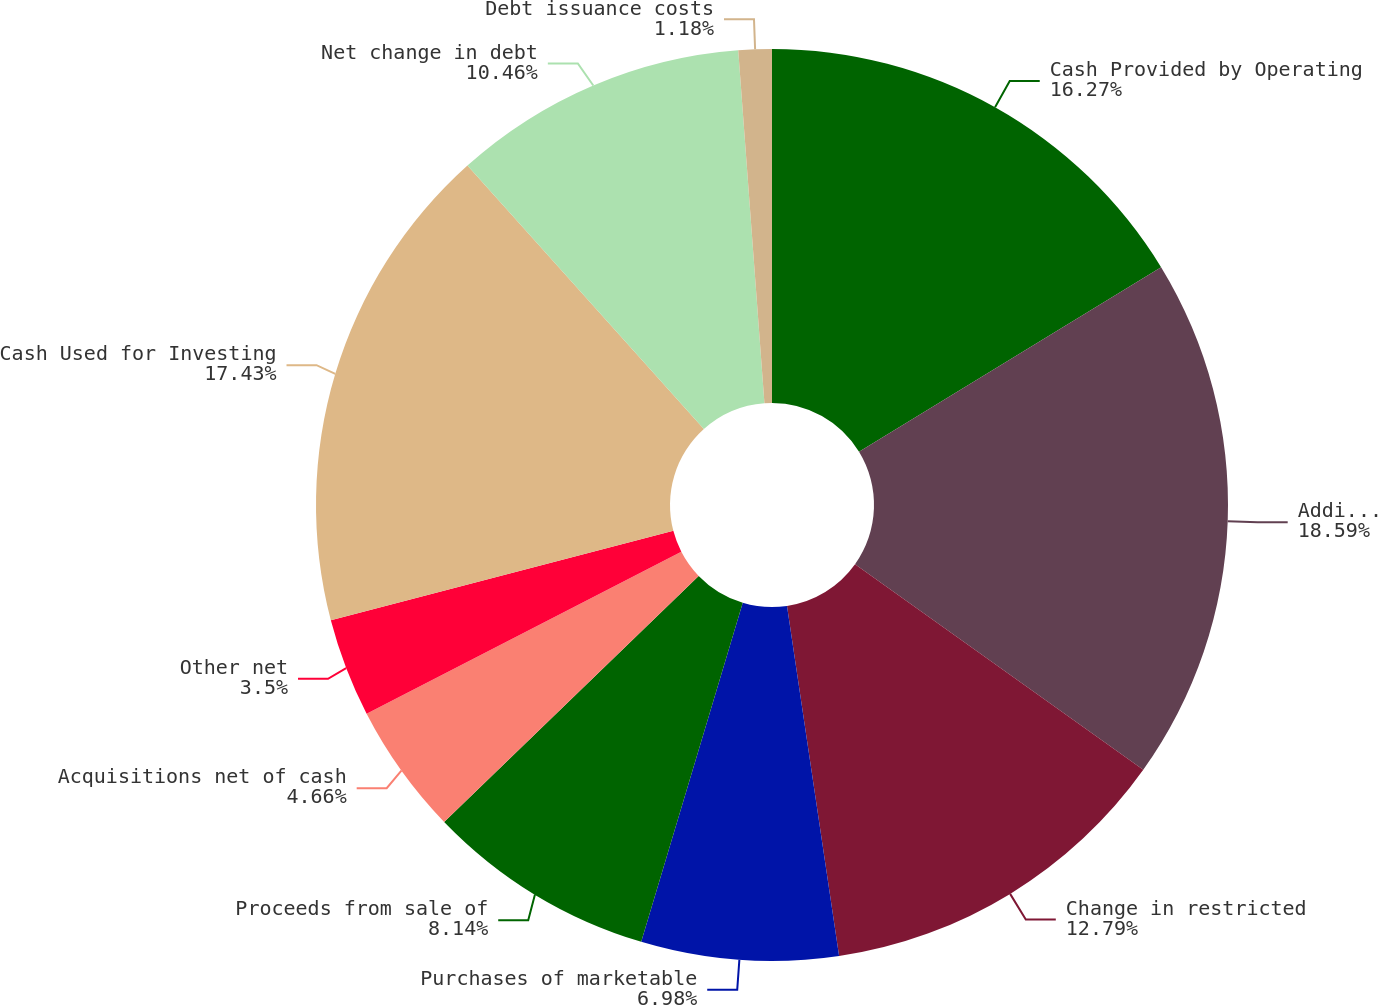Convert chart to OTSL. <chart><loc_0><loc_0><loc_500><loc_500><pie_chart><fcel>Cash Provided by Operating<fcel>Additions to property plant<fcel>Change in restricted<fcel>Purchases of marketable<fcel>Proceeds from sale of<fcel>Acquisitions net of cash<fcel>Other net<fcel>Cash Used for Investing<fcel>Net change in debt<fcel>Debt issuance costs<nl><fcel>16.27%<fcel>18.59%<fcel>12.79%<fcel>6.98%<fcel>8.14%<fcel>4.66%<fcel>3.5%<fcel>17.43%<fcel>10.46%<fcel>1.18%<nl></chart> 